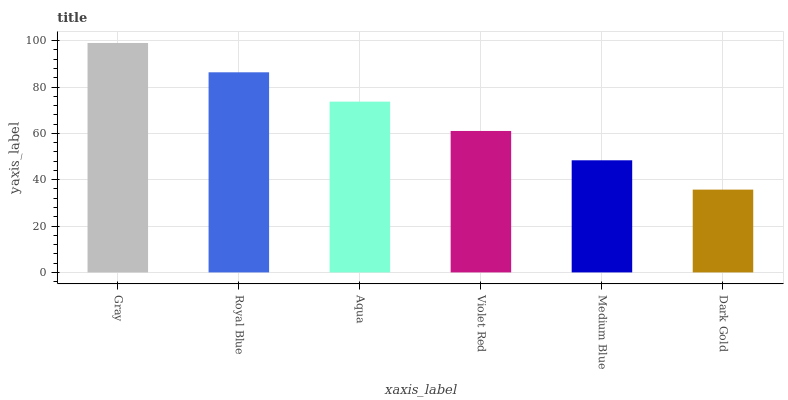Is Royal Blue the minimum?
Answer yes or no. No. Is Royal Blue the maximum?
Answer yes or no. No. Is Gray greater than Royal Blue?
Answer yes or no. Yes. Is Royal Blue less than Gray?
Answer yes or no. Yes. Is Royal Blue greater than Gray?
Answer yes or no. No. Is Gray less than Royal Blue?
Answer yes or no. No. Is Aqua the high median?
Answer yes or no. Yes. Is Violet Red the low median?
Answer yes or no. Yes. Is Medium Blue the high median?
Answer yes or no. No. Is Gray the low median?
Answer yes or no. No. 